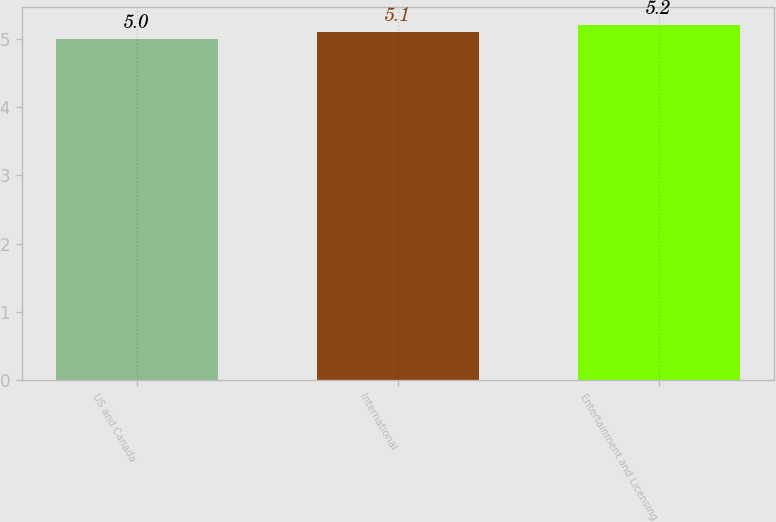<chart> <loc_0><loc_0><loc_500><loc_500><bar_chart><fcel>US and Canada<fcel>International<fcel>Entertainment and Licensing<nl><fcel>5<fcel>5.1<fcel>5.2<nl></chart> 